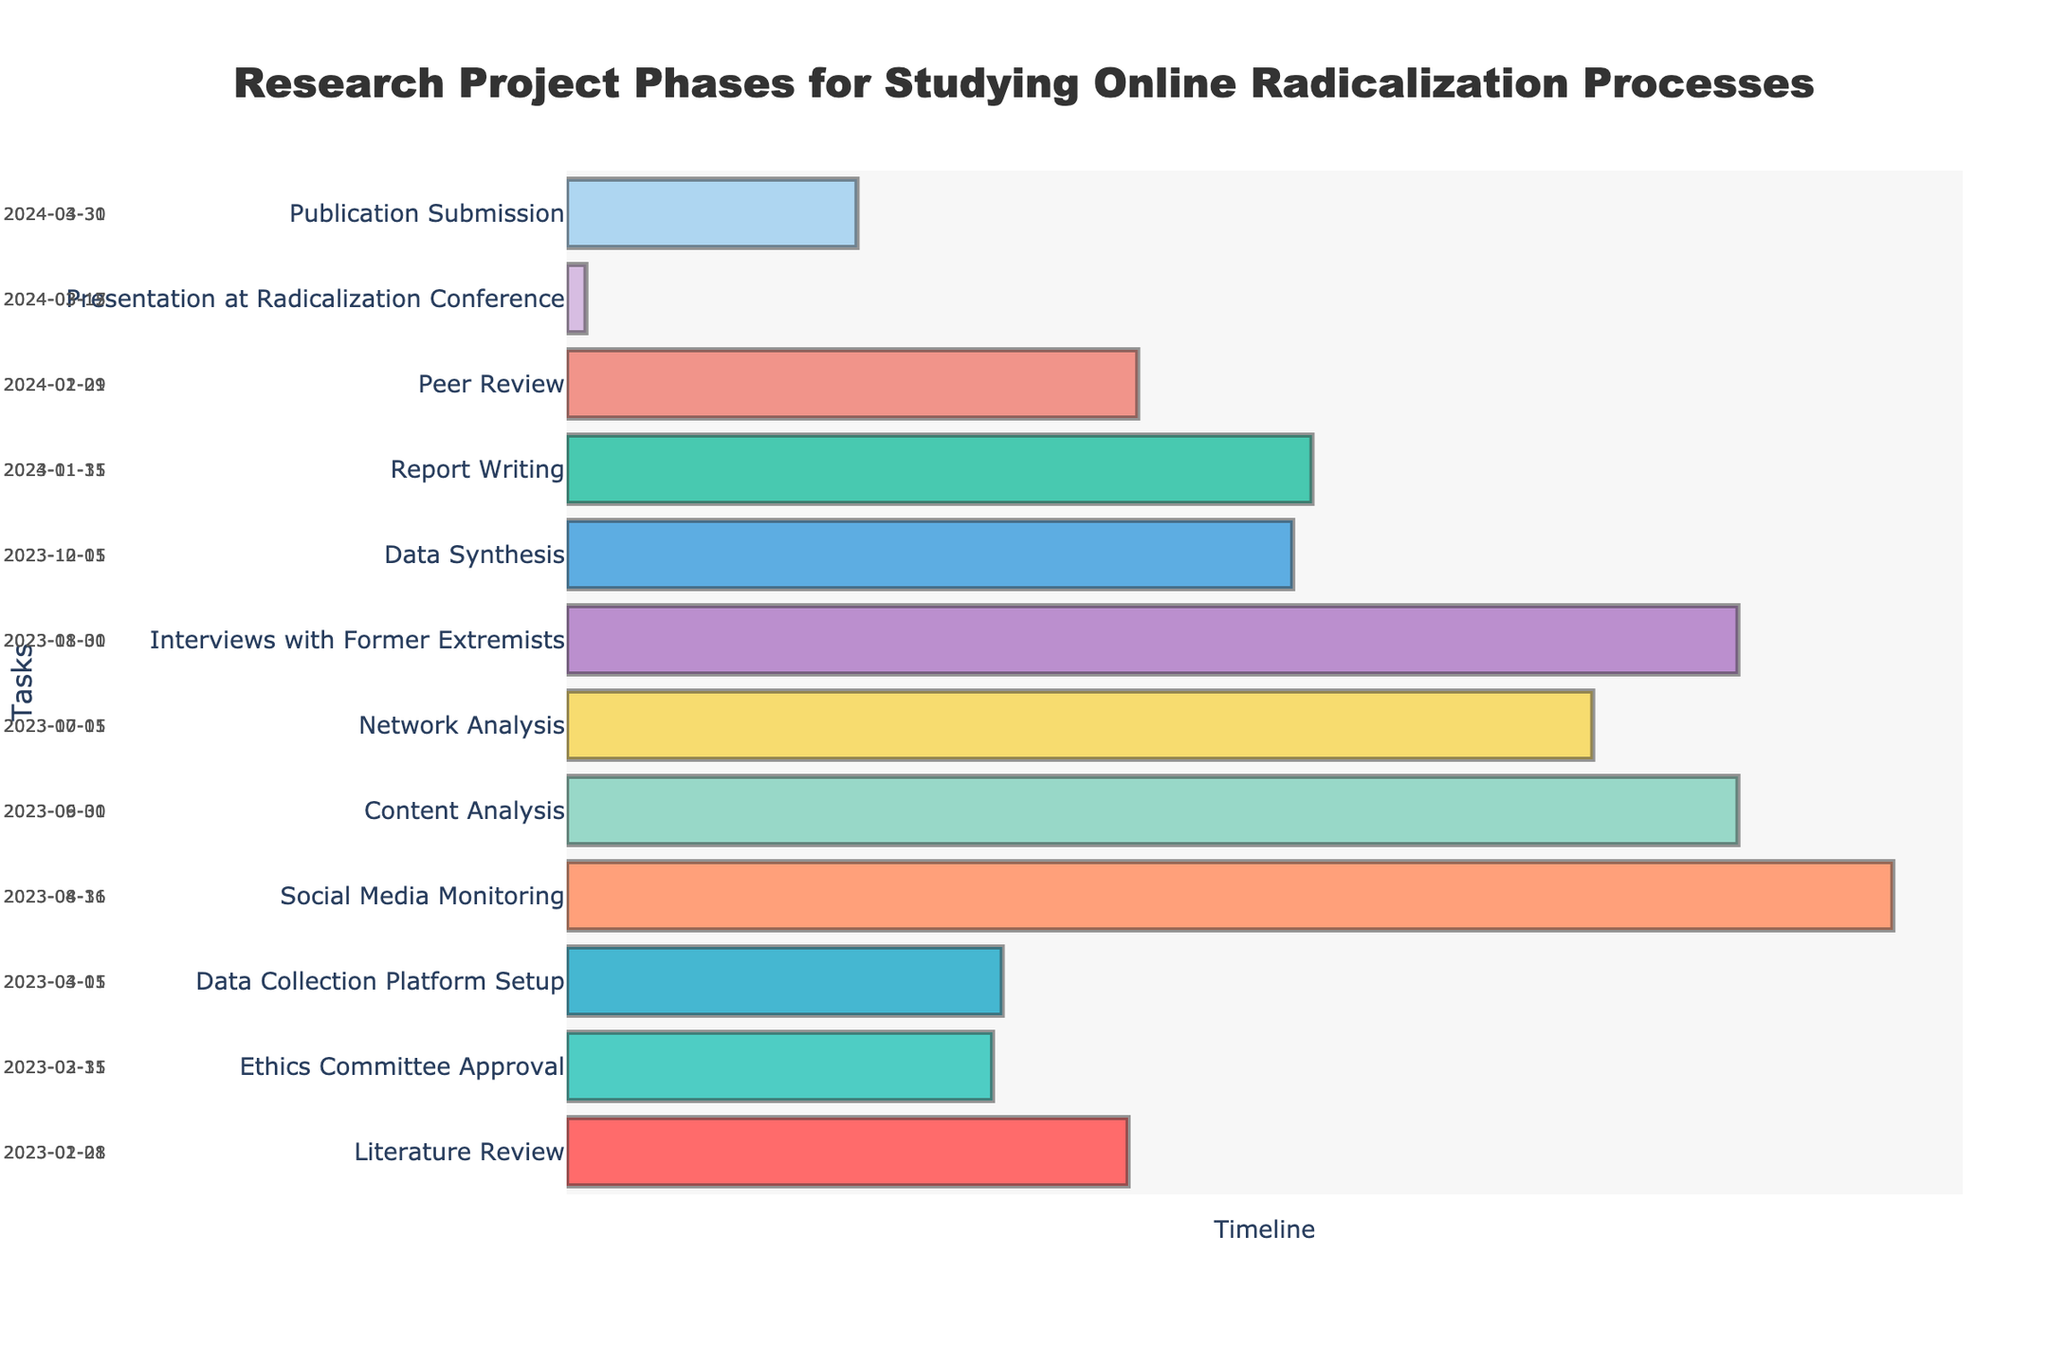What is the starting date of the "Data Collection Platform Setup" task? The "Data Collection Platform Setup" task has its start date displayed directly on the Gantt Chart. By locating this task on the y-axis and looking at the start date annotation, the start date is revealed.
Answer: 2023-03-01 Which task has the longest duration? To determine the longest duration, we need to visually inspect the Gantt Chart bars to see which extends the longest duration between the start and end dates. The task "Social Media Monitoring" spans from 2023-04-16 to 2023-08-31, which gives the longest duration.
Answer: Social Media Monitoring How many tasks have an end date in 2023? By observing the end dates annotated on the Gantt Chart, count the number of tasks that end within the year 2023. There are eight tasks with end dates in 2023.
Answer: 8 When does the "Literature Review" phase begin and end? Refer to the "Literature Review" task on the Gantt Chart and check the start and end dates annotated on the left and right of the bar, respectively. The start date is 2023-01-01 and the end date is 2023-02-28.
Answer: 2023-01-01 to 2023-02-28 Which two tasks are scheduled to overlap entirely based on their duration? Examine the start and end dates of each task to identify any overlap where one task's entire duration is confined within another's. "Ethics Committee Approval" (2023-02-15 to 2023-03-31) overlaps with "Literature Review" (2023-01-01 to 2023-02-28) for the given duration.
Answer: Ethics Committee Approval and Literature Review Which task follows immediately after "Social Media Monitoring"? By looking at the end date of "Social Media Monitoring" (2023-08-31) and finding the task that begins immediately afterward, "Content Analysis" (2023-06-01 to 2023-09-30) fits this criterion. However, one should instead follow the task that starts directly next in the timeline overlap-free, which is "Network Analysis" starting from 2023-07-01.
Answer: Network Analysis What is the timeframe for the "Presentation at Radicalization Conference"? Locate the "Presentation at Radicalization Conference" task on the Gantt chart; its start and end dates are annotated. The task runs from 2024-03-15 to 2024-03-17.
Answer: 2024-03-15 to 2024-03-17 How many tasks are scheduled to take place in August 2023? Review the tasks to see how many have an overlap with August 2023 by checking their start and end dates. Four tasks are scheduled to take place in August 2023.
Answer: 4 